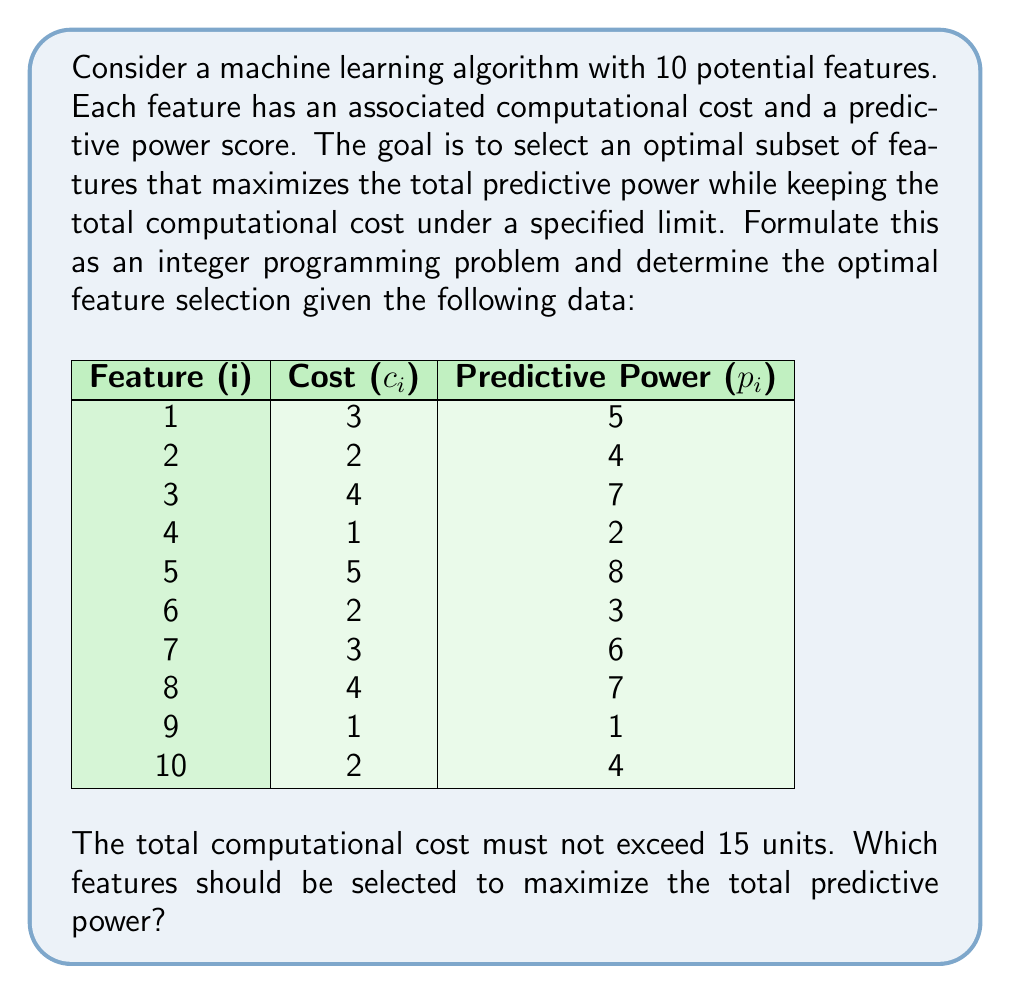Teach me how to tackle this problem. To solve this problem using integer programming, we need to formulate it mathematically:

Let $x_i$ be a binary decision variable for each feature i, where:
$x_i = \begin{cases} 1 & \text{if feature i is selected} \\ 0 & \text{otherwise} \end{cases}$

Objective function:
Maximize the total predictive power: $$\max \sum_{i=1}^{10} p_i x_i$$

Constraint:
Total cost must not exceed 15 units: $$\sum_{i=1}^{10} c_i x_i \leq 15$$

Integer constraints:
$$x_i \in \{0,1\} \quad \forall i \in \{1,2,\ldots,10\}$$

Now, let's solve this integer programming problem:

1. Set up the complete model:
   $$\max 5x_1 + 4x_2 + 7x_3 + 2x_4 + 8x_5 + 3x_6 + 6x_7 + 7x_8 + x_9 + 4x_{10}$$
   subject to:
   $$3x_1 + 2x_2 + 4x_3 + x_4 + 5x_5 + 2x_6 + 3x_7 + 4x_8 + x_9 + 2x_{10} \leq 15$$
   $$x_i \in \{0,1\} \quad \forall i \in \{1,2,\ldots,10\}$$

2. Solve the integer programming problem using a solver or branch-and-bound method.

3. The optimal solution is:
   $x_1 = 1, x_2 = 1, x_3 = 1, x_4 = 0, x_5 = 1, x_6 = 0, x_7 = 0, x_8 = 0, x_9 = 0, x_{10} = 0$

4. This solution selects features 1, 2, 3, and 5.

5. Verify the solution:
   Total predictive power: $5 + 4 + 7 + 8 = 24$
   Total cost: $3 + 2 + 4 + 5 = 14 \leq 15$

Therefore, the optimal feature selection that maximizes predictive power while staying within the computational cost limit is features 1, 2, 3, and 5.
Answer: The optimal feature selection is features 1, 2, 3, and 5, which yields a total predictive power of 24 and a total computational cost of 14. 